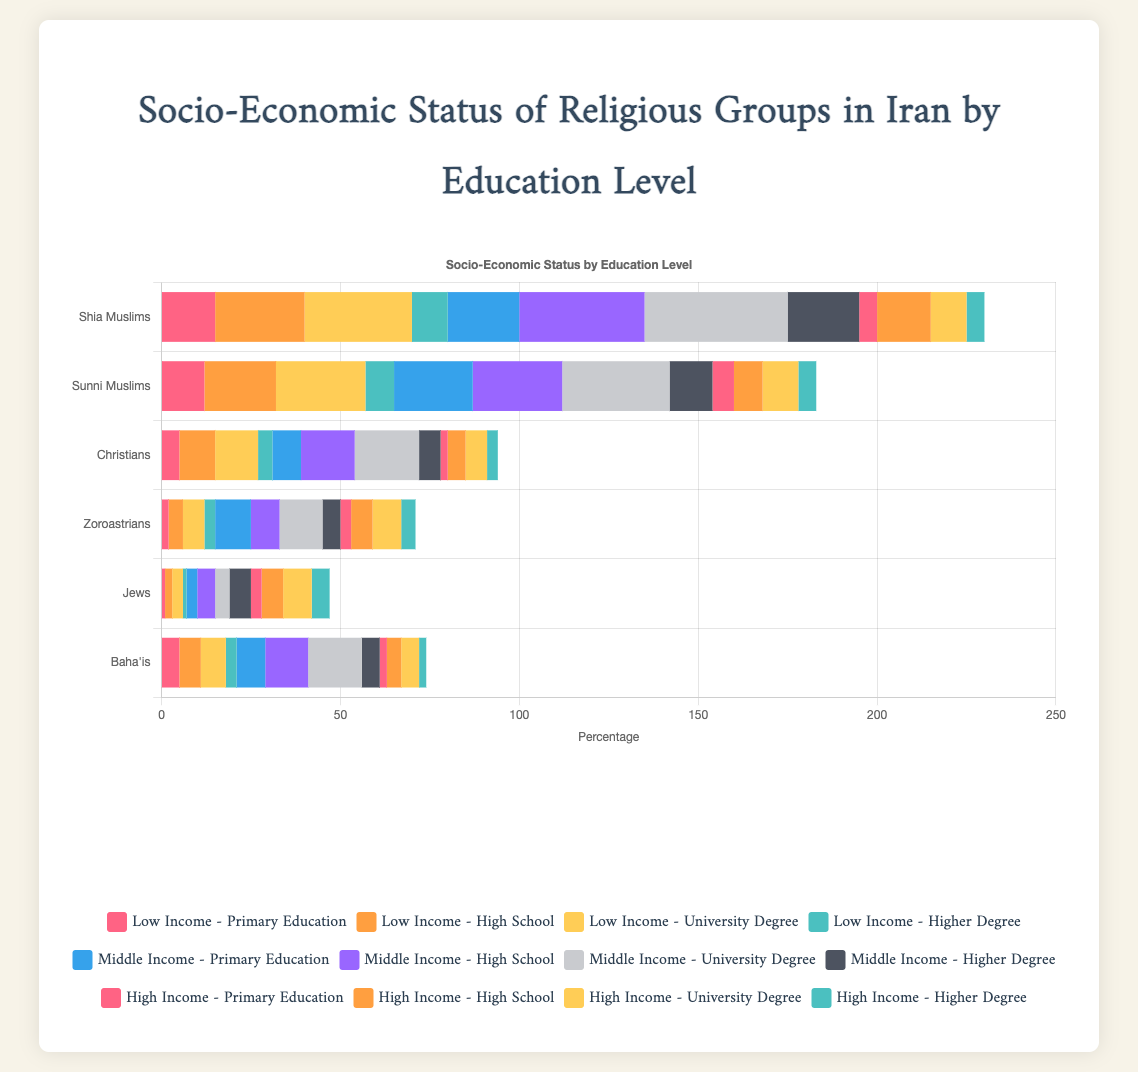What is the total percentage of low-income individuals among Shia Muslims with primary education and high school education? The data shows that Shia Muslims with low income have 15% with primary education and 25% with high school education. Summing these two percentages gives 15 + 25 = 40%.
Answer: 40% Which religious group has the highest percentage of middle-income individuals with university degrees? By observing the middle-income with university degrees category, Shia Muslims have 40%, Sunni Muslims have 30%, Christians have 18%, Zoroastrians have 12%, Jews have 4%, and Baha'is have 15%. The highest value is 40% for Shia Muslims.
Answer: Shia Muslims How does the percentage of high-income individuals with higher degrees compare between Jews and Zoroastrians? Jews have 5% and Zoroastrians have 4% in the high-income with higher degrees category. Therefore, Jews have a higher percentage by 1%.
Answer: Jews have 1% more What is the average percentage of Christians with low income across all education levels? The values for Christians with low income are 5% (primary education), 10% (high school), 12% (university degree), and 4% (higher degree). The sum is 5 + 10 + 12 + 4 = 31, and the average is 31/4 = 7.75%.
Answer: 7.75% Which group has the lowest percentage of middle-income individuals with primary education? Examining the middle-income with primary education category: Shia Muslims have 20%, Sunni Muslims 22%, Christians 8%, Zoroastrians 10%, Jews 3%, and Baha'is 8%. Jews have the lowest percentage at 3%.
Answer: Jews What is the total percentage of high-income individuals among Baha'is across all education levels? The percentages for Baha'is with high income are 2% (primary education), 4% (high school), 5% (university degree), and 2% (higher degree). Summing these gives 2 + 4 + 5 + 2 = 13%.
Answer: 13% Which religious group has the highest low-income percentage (across any education level) and what is that percentage? The data shows that Shia Muslims have the highest value in any category with low-income and high school education at 25%.
Answer: Shia Muslims have 25% with high school For Zoroastrians, what is the difference between the percentage of high-income individuals with university degrees and middle-income individuals with the same education level? Zoroastrians have 8% high-income and 12% middle-income individuals with university degrees. The difference is 12 - 8 = 4%.
Answer: 4% Among Sunni Muslims, what is the combined percentage of low-income individuals with university degrees and higher degrees? The values for low-income Sunni Muslims are 25% (university degree) and 8% (higher degree). Summing these gives 25 + 8 = 33%.
Answer: 33% What is the visual indicator (color) used for high-income individuals with undergraduate degrees on the chart? The color used for high-income with university degrees is the same as for other high-income segments, which is yellow (#FFCD56).
Answer: Yellow 